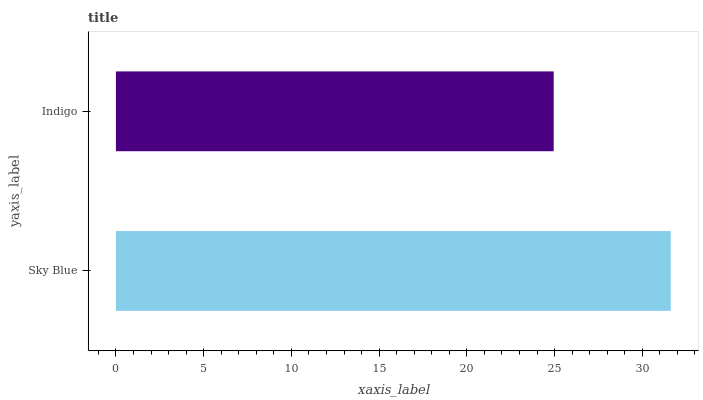Is Indigo the minimum?
Answer yes or no. Yes. Is Sky Blue the maximum?
Answer yes or no. Yes. Is Indigo the maximum?
Answer yes or no. No. Is Sky Blue greater than Indigo?
Answer yes or no. Yes. Is Indigo less than Sky Blue?
Answer yes or no. Yes. Is Indigo greater than Sky Blue?
Answer yes or no. No. Is Sky Blue less than Indigo?
Answer yes or no. No. Is Sky Blue the high median?
Answer yes or no. Yes. Is Indigo the low median?
Answer yes or no. Yes. Is Indigo the high median?
Answer yes or no. No. Is Sky Blue the low median?
Answer yes or no. No. 